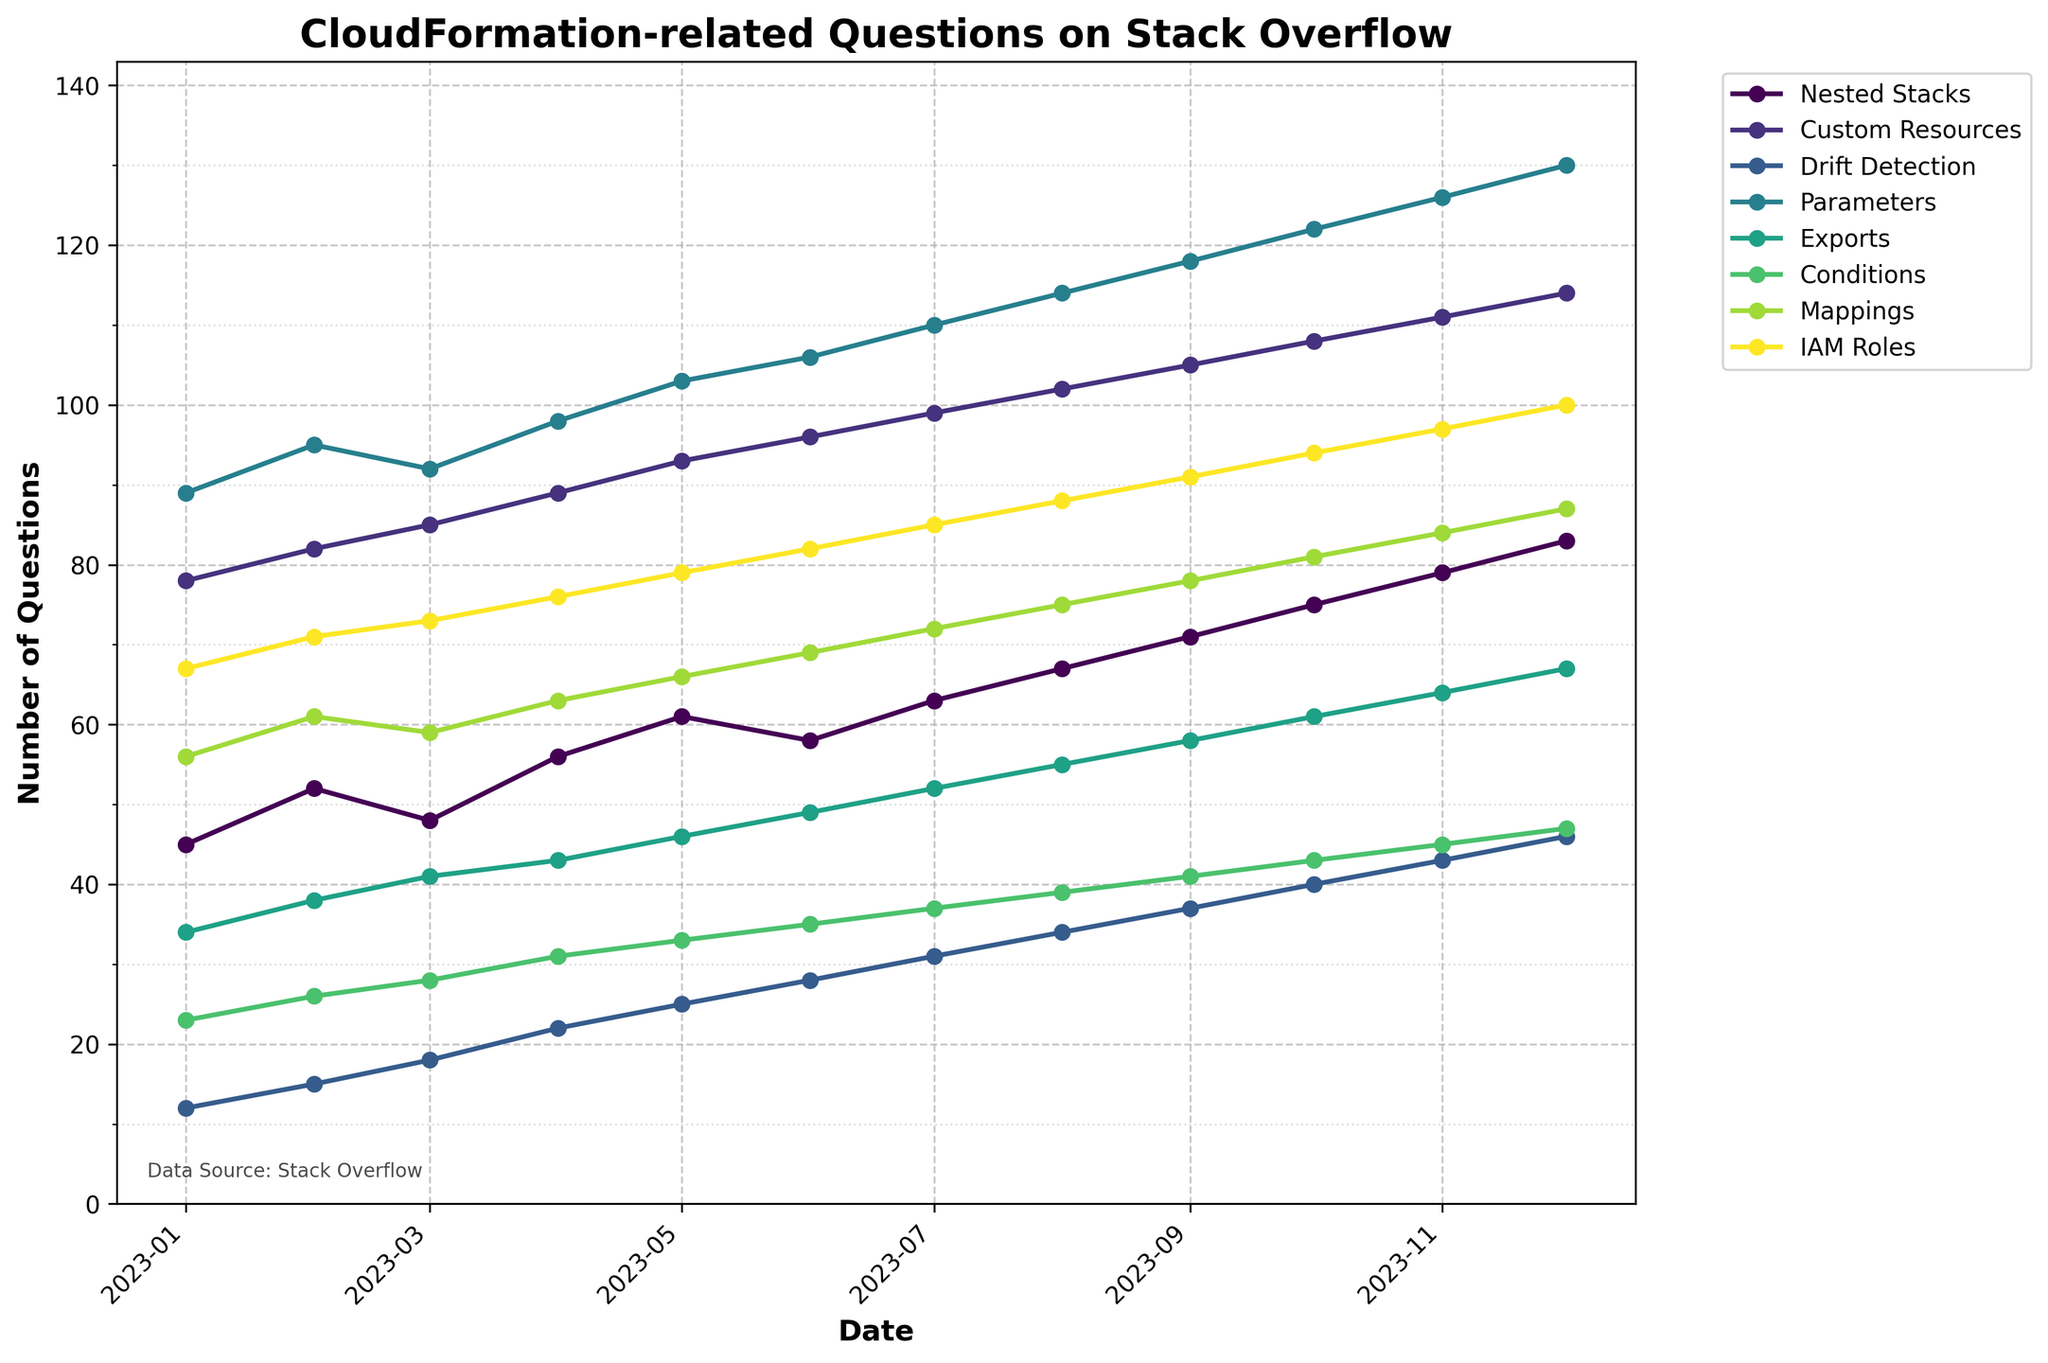Which topic had the highest number of questions in January 2023? Review the data for January 2023 and identify the topic with the maximum questions.
Answer: Parameters Did the number of questions about Nested Stacks increase or decrease in March 2023 compared to February 2023? Compare the values for Nested Stacks in February 2023 (52) and March 2023 (48). Since 48 is less than 52, it decreased.
Answer: Decrease Which two topics had an equal number of questions in April 2023? Review the data for April 2023 and find which topics have the same value. Custom Resources and Parameters both have 98 questions.
Answer: Custom Resources and Parameters By how many did the questions about Drift Detection increase from January to December 2023? Subtract the number of questions in January 2023 from the number in December 2023 for Drift Detection. 46 - 12 = 34.
Answer: 34 In which month did Exports overtake Nested Stacks in the number of questions for the first time? Compare each month’s values for Exports and Nested Stacks until Exports has a higher value. This occurs in October 2023 (Exports = 61, Nested Stacks = 75, where 75 > 61).
Answer: Never Which topic showed the most consistent month-to-month growth across the entire year? Evaluate the month-to-month differences for each topic. Custom Resources increases linearly by 3 each month, indicating the most consistent growth.
Answer: Custom Resources How many more questions were asked about IAM Roles than Drift Detection in November 2023? Subtract the number of questions for Drift Detection from those for IAM Roles in November. 97 - 43 = 54.
Answer: 54 Which topic showed the highest peak of questions in any month, and how many questions were there? Identify the highest value in the dataset across all topics and months. IAM Roles in December had 100 questions.
Answer: IAM Roles, 100 What was the average number of questions asked about Conditions over the 12 months? Sum the values for Conditions and divide by 12. (23+26+28+31+33+35+37+39+41+43+45+47)/12 ≈ 33.25.
Answer: 33.25 